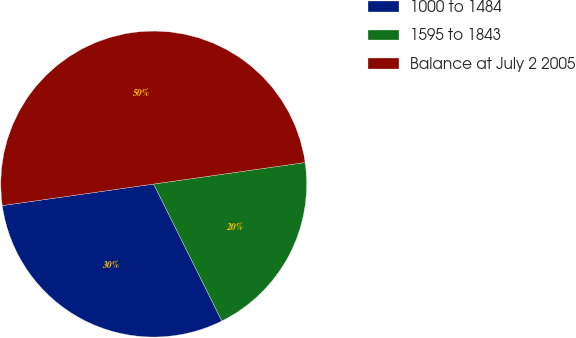<chart> <loc_0><loc_0><loc_500><loc_500><pie_chart><fcel>1000 to 1484<fcel>1595 to 1843<fcel>Balance at July 2 2005<nl><fcel>30.1%<fcel>19.9%<fcel>50.0%<nl></chart> 